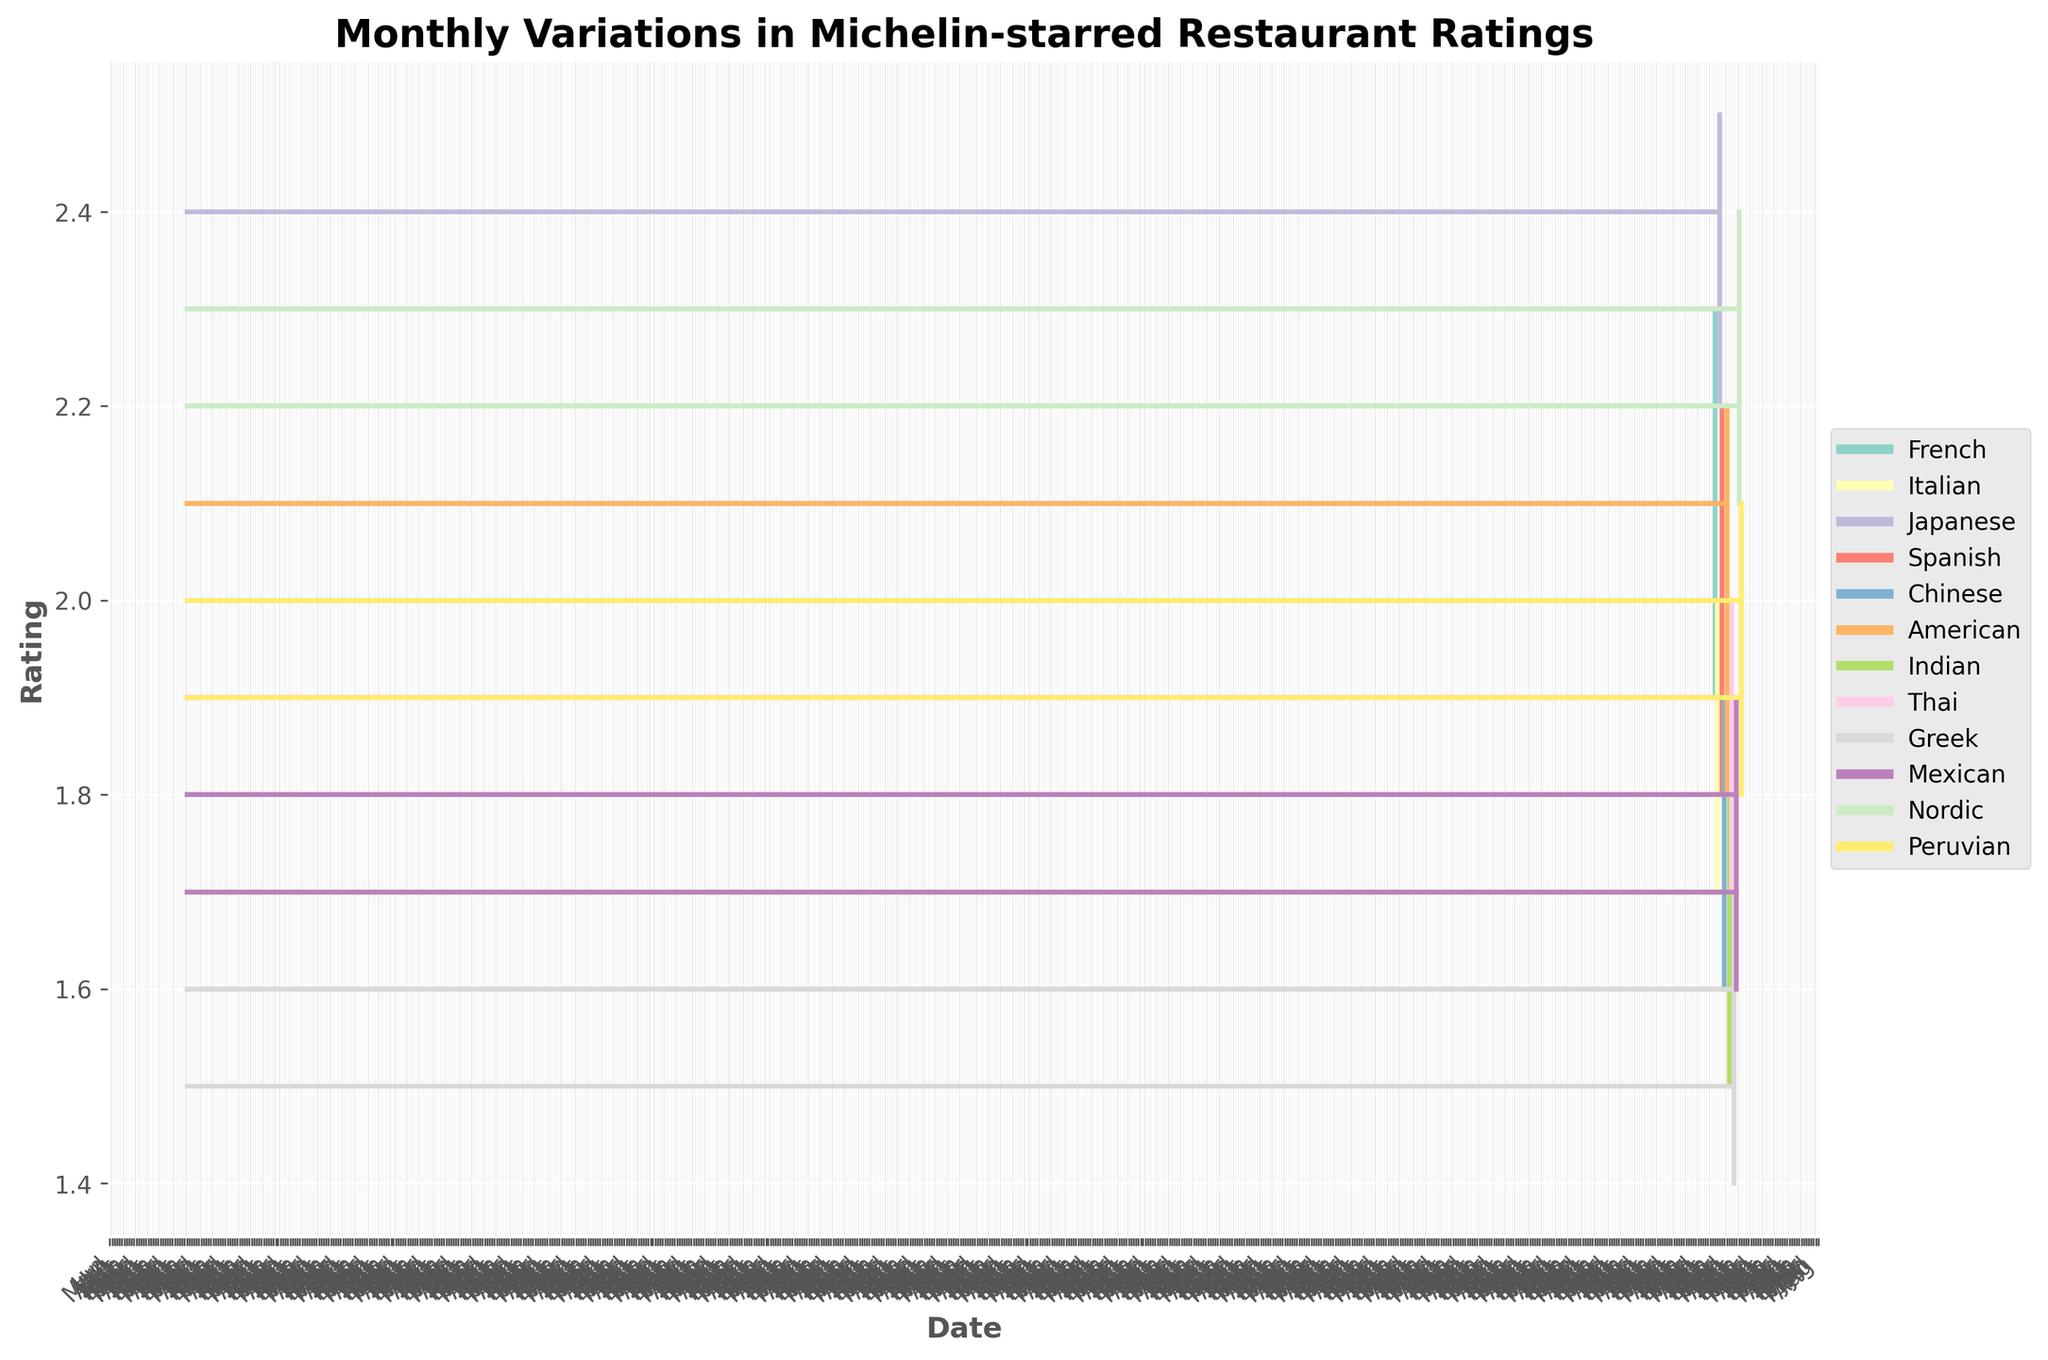How many types of cuisines are displayed in the chart? The legend of the chart lists all the cuisines represented. Each cuisine has a unique color. Counting the cuisines listed in the legend gives us the total number of types.
Answer: 12 Which cuisine had the highest "High" value in 2023? To find the cuisine with the highest "High" value, look at the High values on the vertical lines in the plot. The highest value is 2.5, found in March for Japanese cuisine.
Answer: Japanese What is the total range of ratings for the Chinese cuisine? The range is calculated by subtracting the "Low" value from the "High" value for the Chinese cuisine, which occurred in May. The values are 1.9 (High) and 1.6 (Low). The range is 1.9 - 1.6.
Answer: 0.3 Which month had the lowest "Low" value, and for which cuisine? Look at the lowest points on the vertical lines across all months. The lowest value is 1.4, which occurred in September for Greek cuisine.
Answer: September, Greek What is the average "Close" value for all cuisines in 2023? Add up all the "Close" values for each cuisine (2.2+1.9+2.4+2.1+1.8+2.1+1.7+1.9+1.6+1.8+2.3+2.0) and divide by the number of cuisines (12). The total is 26.8, and the average is 26.8/12.
Answer: 2.233 Which cuisines closed higher than they opened within the given months? Compare the "Open" and "Close" values for each cuisine. The "Close" is higher than the "Open" if the value on the right (Close) is higher than the left (Open) on individual horizontal ticks. French (January: 2.2 > 2.1), Japanese (March: 2.4 > 2.3), Spanish (April: 2.1 > 1.9), American (June: 2.1 > 2.0), Mexican (October: 1.8 > 1.7), Nordic (November: 2.3 > 2.2)
Answer: French, Japanese, Spanish, American, Mexican, Nordic Which cuisine had the smallest variation in its ratings, and what is this variation? Check each month’s vertical line to determine the difference between High and Low values for each cuisine. The smallest variation is for Italian cuisine in February, where the values are 2.0 (High) and 1.7 (Low). The variation is 2.0 - 1.7.
Answer: Italian, 0.3 How does the range of ratings for Nordic cuisine compare to that of Greek cuisine? Calculate the range for Nordic (2.4 High - 2.1 Low = 0.3) and Greek (1.7 High - 1.4 Low = 0.3). Both ranges are 0.3, so they are equal.
Answer: Equal Which cuisines did not have any month where the "Close" value was less than 2.0? Reviewing the "Close" values, only French (January: 2.2), Japanese (March: 2.4), American (June: 2.1), and Nordic (November: 2.3) have only values higher than 2.0.
Answer: French, Japanese, American, Nordic 